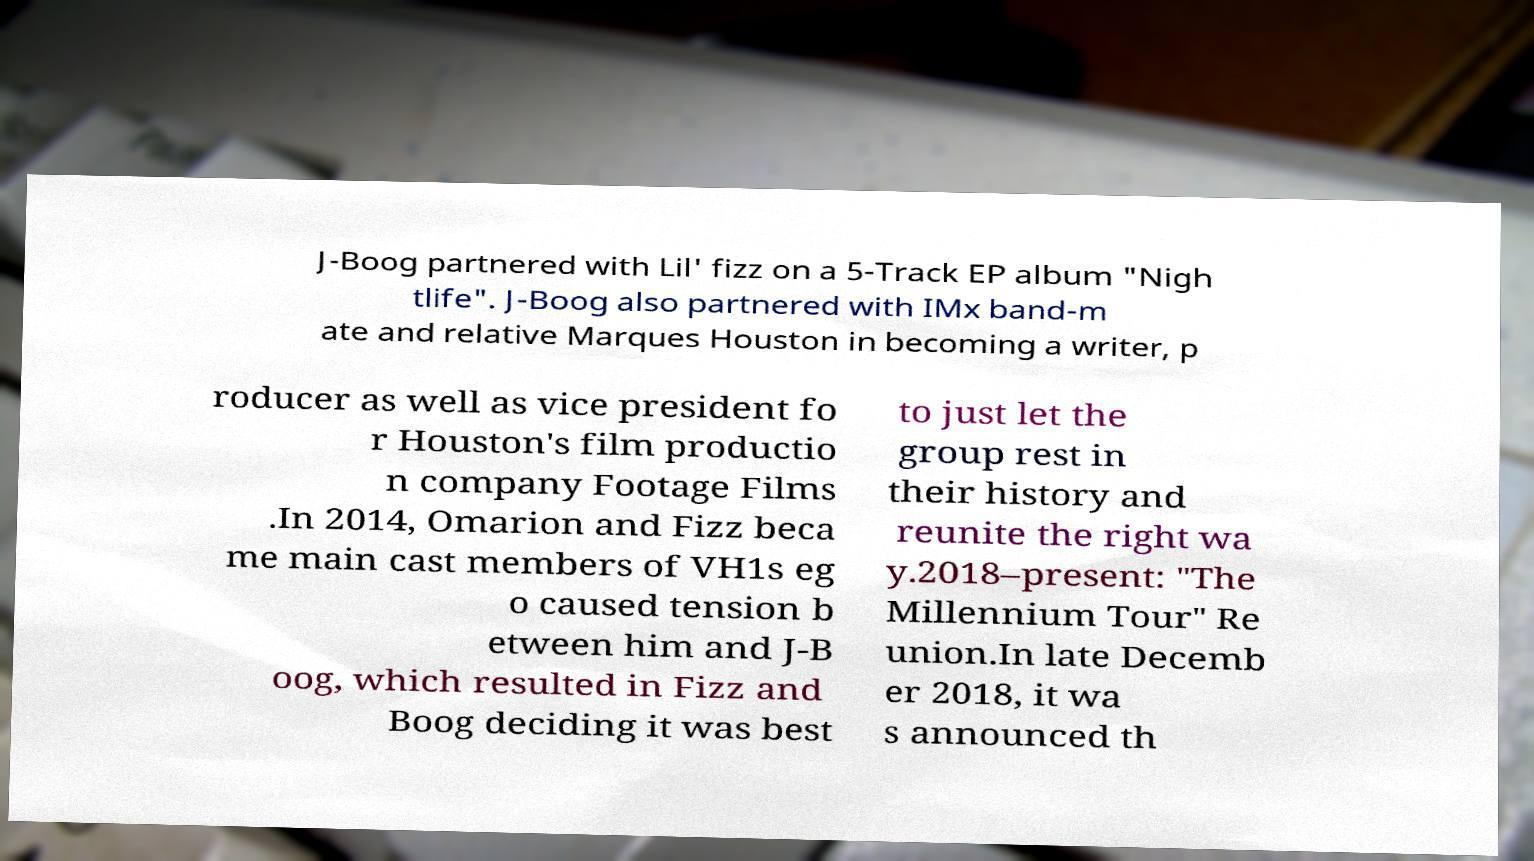Can you accurately transcribe the text from the provided image for me? J-Boog partnered with Lil' fizz on a 5-Track EP album "Nigh tlife". J-Boog also partnered with IMx band-m ate and relative Marques Houston in becoming a writer, p roducer as well as vice president fo r Houston's film productio n company Footage Films .In 2014, Omarion and Fizz beca me main cast members of VH1s eg o caused tension b etween him and J-B oog, which resulted in Fizz and Boog deciding it was best to just let the group rest in their history and reunite the right wa y.2018–present: "The Millennium Tour" Re union.In late Decemb er 2018, it wa s announced th 